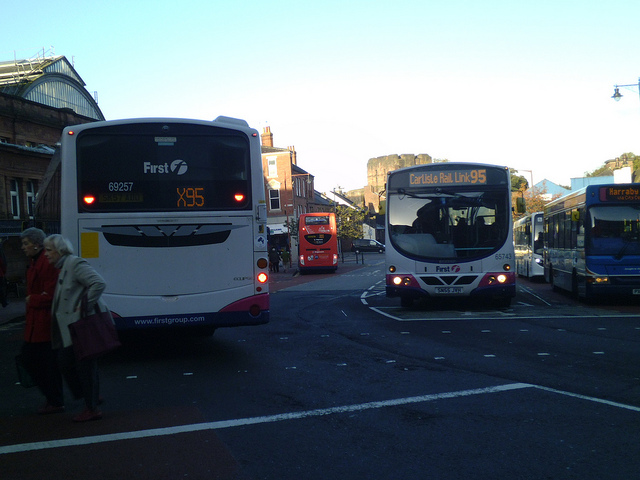<image>How many people are  there? I don't know how many people are there. It can be either 1 or 2. How many people are  there? I am not sure how many people are there. It can be seen either 1 or 2. 